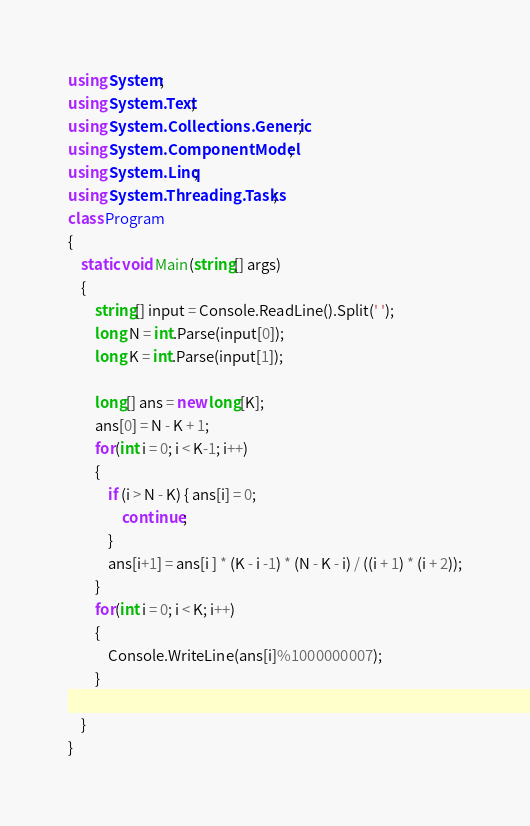<code> <loc_0><loc_0><loc_500><loc_500><_C#_>using System;
using System.Text;
using System.Collections.Generic;
using System.ComponentModel;
using System.Linq;
using System.Threading.Tasks;
class Program
{
	static void Main(string[] args)
	{
		string[] input = Console.ReadLine().Split(' ');
		long N = int.Parse(input[0]);
		long K = int.Parse(input[1]);

		long[] ans = new long[K];
		ans[0] = N - K + 1;
        for(int i = 0; i < K-1; i++)
		{
			if (i > N - K) { ans[i] = 0;
				continue;
			}
			ans[i+1] = ans[i ] * (K - i -1) * (N - K - i) / ((i + 1) * (i + 2));
		}
        for(int i = 0; i < K; i++)
		{
			Console.WriteLine(ans[i]%1000000007);
		}
        
    }
}
</code> 